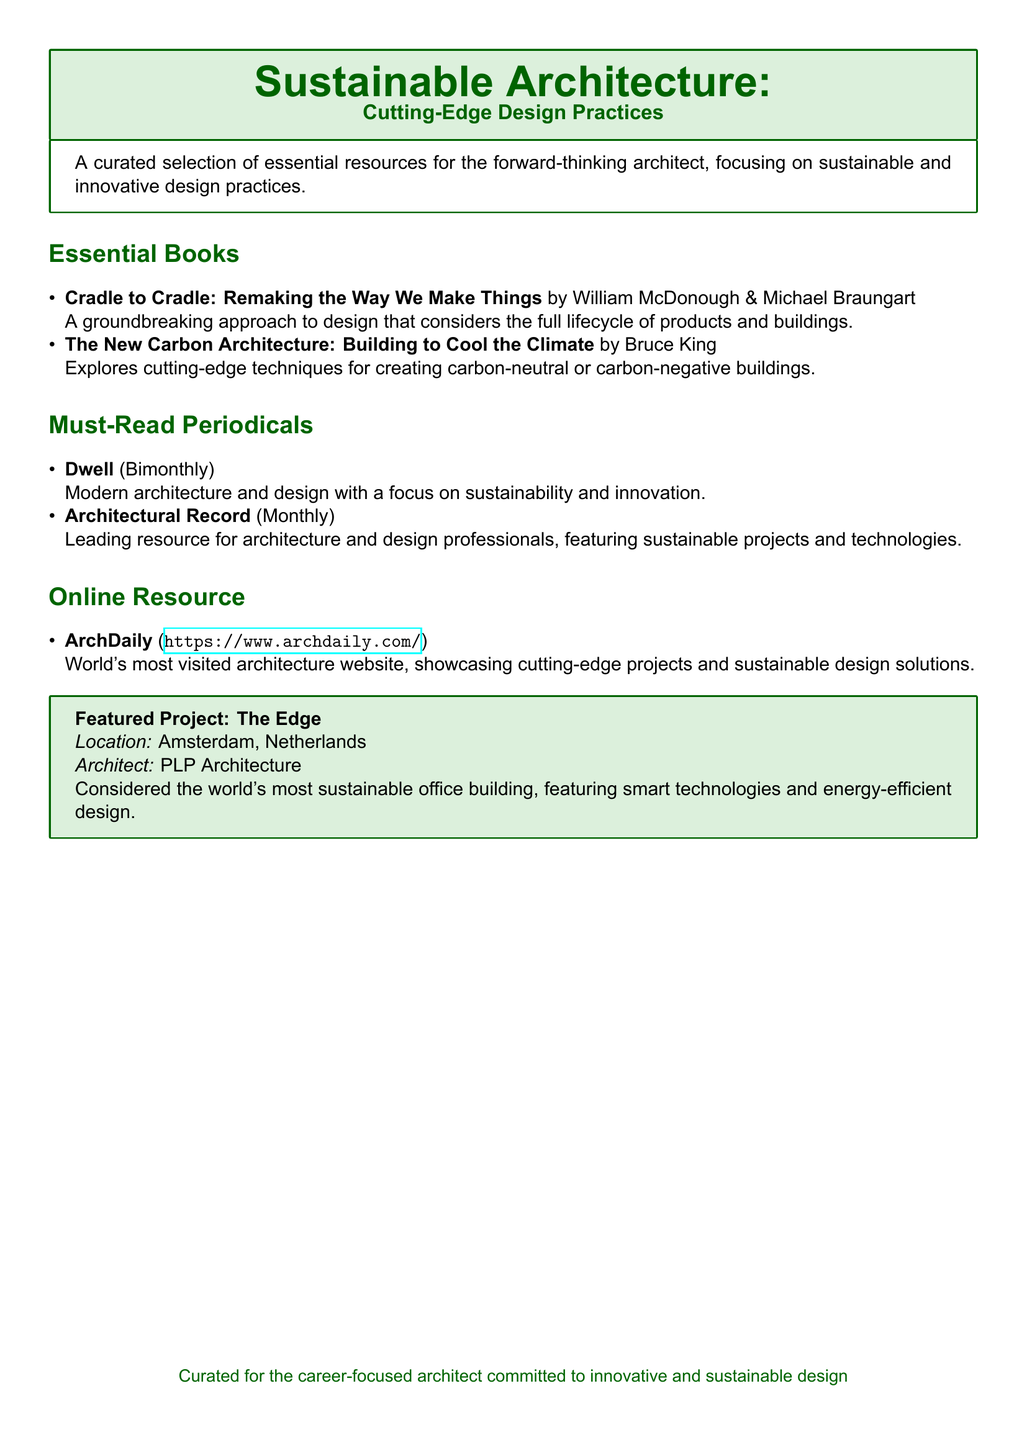What is the title of the first book listed? The first book listed is named "Cradle to Cradle: Remaking the Way We Make Things".
Answer: Cradle to Cradle: Remaking the Way We Make Things Who are the authors of "The New Carbon Architecture"? The authors of "The New Carbon Architecture" are Bruce King.
Answer: Bruce King How often is "Dwell" published? "Dwell" is described as a bimonthly periodical.
Answer: Bimonthly What is the website of the online resource mentioned? The online resource "ArchDaily" is accessible at its specific URL.
Answer: https://www.archdaily.com/ Where is The Edge located? The Edge is located in Amsterdam, Netherlands.
Answer: Amsterdam, Netherlands Which company is the architect of The Edge? The architect of The Edge is PLP Architecture.
Answer: PLP Architecture What is the main focus of the curated selection in the document? The main focus is on sustainable and innovative design practices for architects.
Answer: Sustainable and innovative design practices What color is used for the document's title section? The title section is designed using the color dark green.
Answer: Dark green 